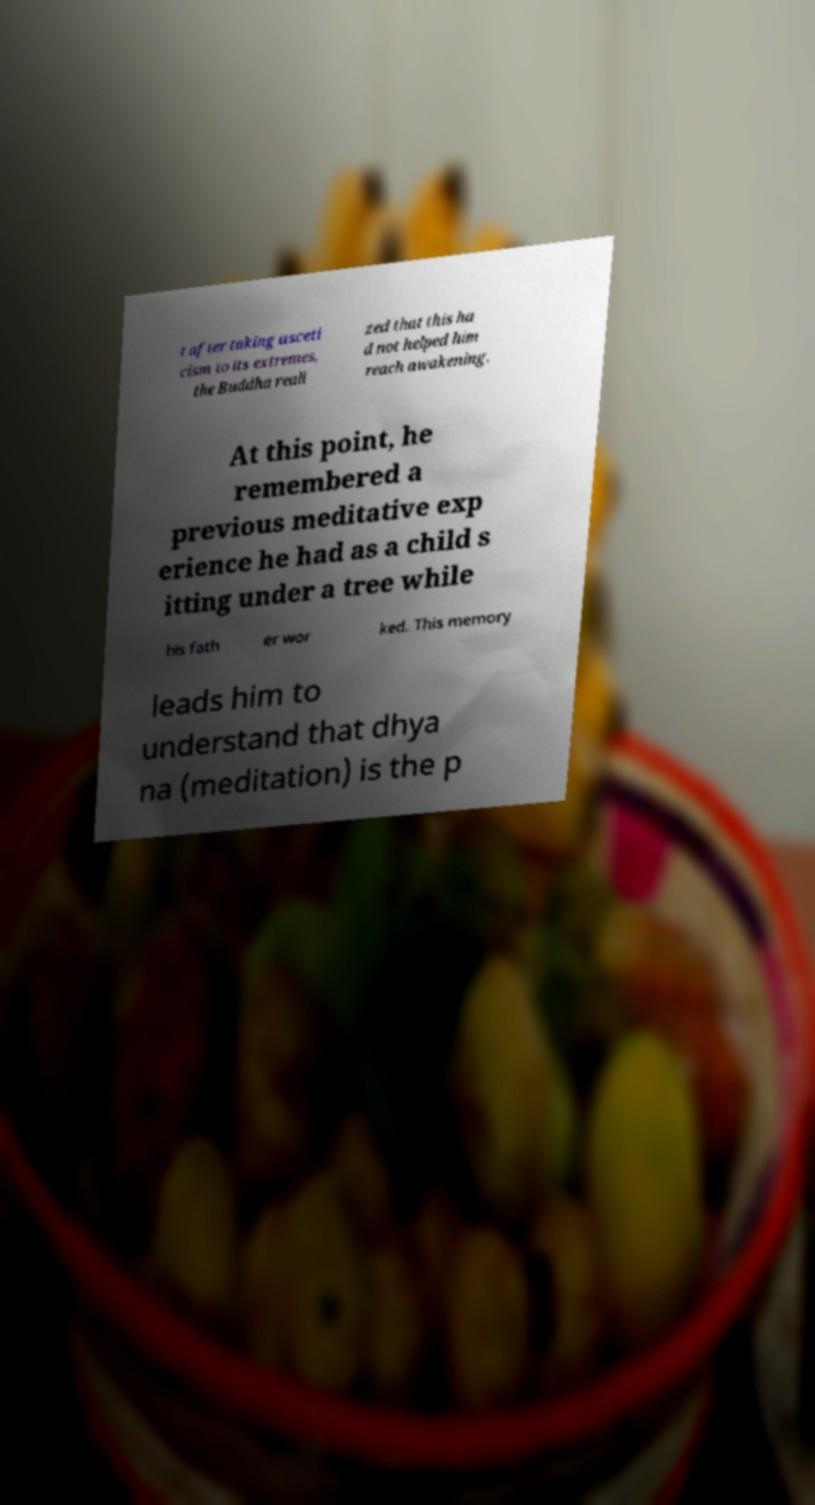Please read and relay the text visible in this image. What does it say? t after taking asceti cism to its extremes, the Buddha reali zed that this ha d not helped him reach awakening. At this point, he remembered a previous meditative exp erience he had as a child s itting under a tree while his fath er wor ked. This memory leads him to understand that dhya na (meditation) is the p 